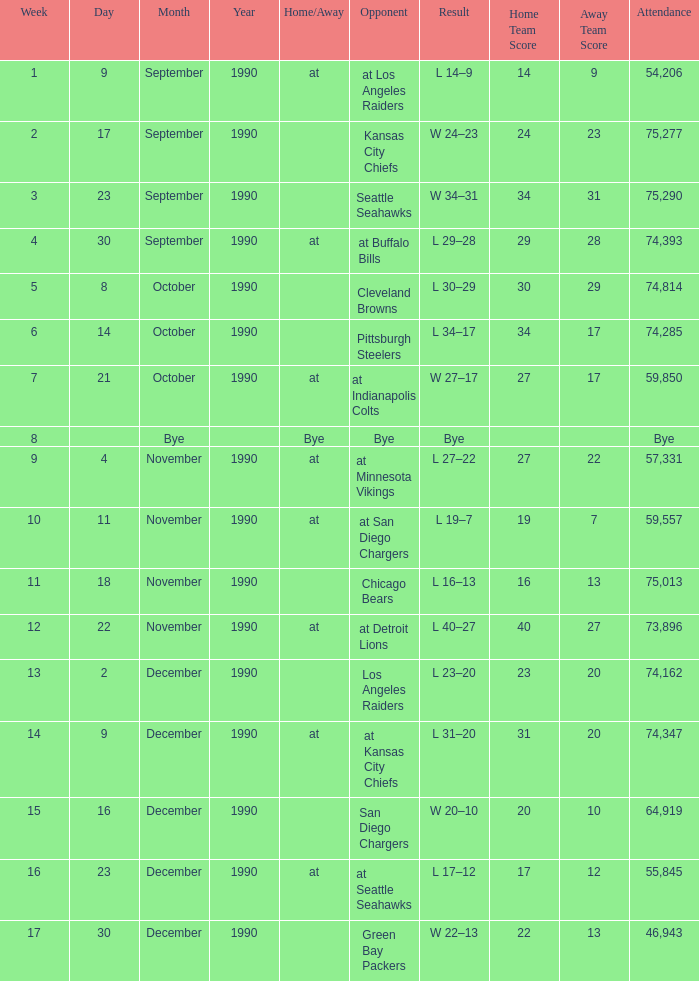What day was the attendance 74,285? October 14, 1990. 